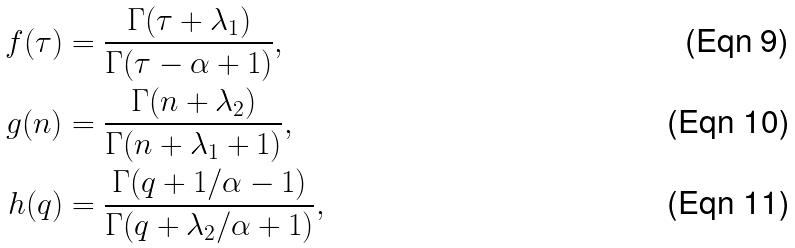Convert formula to latex. <formula><loc_0><loc_0><loc_500><loc_500>f ( \tau ) & = \frac { \Gamma ( \tau + \lambda _ { 1 } ) } { \Gamma ( \tau - \alpha + 1 ) } , \\ g ( n ) & = \frac { \Gamma ( n + \lambda _ { 2 } ) } { \Gamma ( n + \lambda _ { 1 } + 1 ) } , \\ h ( q ) & = \frac { \Gamma ( q + 1 / \alpha - 1 ) } { \Gamma ( q + \lambda _ { 2 } / \alpha + 1 ) } ,</formula> 